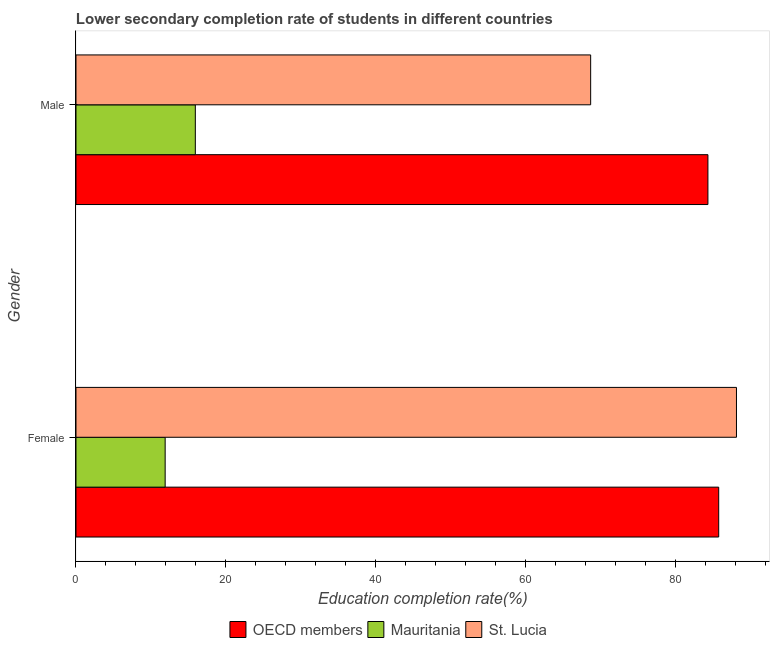How many bars are there on the 2nd tick from the top?
Your answer should be compact. 3. What is the education completion rate of female students in Mauritania?
Offer a very short reply. 11.9. Across all countries, what is the maximum education completion rate of male students?
Keep it short and to the point. 84.36. Across all countries, what is the minimum education completion rate of male students?
Your response must be concise. 15.93. In which country was the education completion rate of female students maximum?
Keep it short and to the point. St. Lucia. In which country was the education completion rate of male students minimum?
Offer a very short reply. Mauritania. What is the total education completion rate of male students in the graph?
Give a very brief answer. 168.99. What is the difference between the education completion rate of female students in St. Lucia and that in Mauritania?
Make the answer very short. 76.27. What is the difference between the education completion rate of female students in Mauritania and the education completion rate of male students in St. Lucia?
Ensure brevity in your answer.  -56.8. What is the average education completion rate of female students per country?
Offer a very short reply. 61.96. What is the difference between the education completion rate of female students and education completion rate of male students in Mauritania?
Offer a very short reply. -4.03. In how many countries, is the education completion rate of female students greater than 20 %?
Make the answer very short. 2. What is the ratio of the education completion rate of female students in OECD members to that in Mauritania?
Provide a succinct answer. 7.21. Is the education completion rate of male students in OECD members less than that in St. Lucia?
Your answer should be compact. No. In how many countries, is the education completion rate of female students greater than the average education completion rate of female students taken over all countries?
Provide a succinct answer. 2. What does the 1st bar from the top in Male represents?
Keep it short and to the point. St. Lucia. What does the 3rd bar from the bottom in Male represents?
Offer a very short reply. St. Lucia. How many countries are there in the graph?
Provide a succinct answer. 3. What is the difference between two consecutive major ticks on the X-axis?
Ensure brevity in your answer.  20. Where does the legend appear in the graph?
Offer a terse response. Bottom center. How many legend labels are there?
Your answer should be very brief. 3. How are the legend labels stacked?
Offer a very short reply. Horizontal. What is the title of the graph?
Offer a terse response. Lower secondary completion rate of students in different countries. Does "Upper middle income" appear as one of the legend labels in the graph?
Provide a succinct answer. No. What is the label or title of the X-axis?
Your response must be concise. Education completion rate(%). What is the Education completion rate(%) in OECD members in Female?
Provide a succinct answer. 85.8. What is the Education completion rate(%) of Mauritania in Female?
Provide a short and direct response. 11.9. What is the Education completion rate(%) in St. Lucia in Female?
Provide a short and direct response. 88.17. What is the Education completion rate(%) in OECD members in Male?
Ensure brevity in your answer.  84.36. What is the Education completion rate(%) of Mauritania in Male?
Your response must be concise. 15.93. What is the Education completion rate(%) in St. Lucia in Male?
Offer a terse response. 68.7. Across all Gender, what is the maximum Education completion rate(%) of OECD members?
Give a very brief answer. 85.8. Across all Gender, what is the maximum Education completion rate(%) in Mauritania?
Your answer should be compact. 15.93. Across all Gender, what is the maximum Education completion rate(%) in St. Lucia?
Your answer should be compact. 88.17. Across all Gender, what is the minimum Education completion rate(%) in OECD members?
Provide a short and direct response. 84.36. Across all Gender, what is the minimum Education completion rate(%) of Mauritania?
Provide a succinct answer. 11.9. Across all Gender, what is the minimum Education completion rate(%) in St. Lucia?
Your answer should be compact. 68.7. What is the total Education completion rate(%) of OECD members in the graph?
Offer a very short reply. 170.15. What is the total Education completion rate(%) in Mauritania in the graph?
Keep it short and to the point. 27.83. What is the total Education completion rate(%) of St. Lucia in the graph?
Your response must be concise. 156.87. What is the difference between the Education completion rate(%) of OECD members in Female and that in Male?
Your response must be concise. 1.44. What is the difference between the Education completion rate(%) of Mauritania in Female and that in Male?
Give a very brief answer. -4.03. What is the difference between the Education completion rate(%) in St. Lucia in Female and that in Male?
Give a very brief answer. 19.46. What is the difference between the Education completion rate(%) of OECD members in Female and the Education completion rate(%) of Mauritania in Male?
Your response must be concise. 69.87. What is the difference between the Education completion rate(%) of OECD members in Female and the Education completion rate(%) of St. Lucia in Male?
Your answer should be compact. 17.09. What is the difference between the Education completion rate(%) of Mauritania in Female and the Education completion rate(%) of St. Lucia in Male?
Ensure brevity in your answer.  -56.8. What is the average Education completion rate(%) in OECD members per Gender?
Offer a terse response. 85.08. What is the average Education completion rate(%) in Mauritania per Gender?
Provide a succinct answer. 13.92. What is the average Education completion rate(%) of St. Lucia per Gender?
Your answer should be very brief. 78.44. What is the difference between the Education completion rate(%) of OECD members and Education completion rate(%) of Mauritania in Female?
Give a very brief answer. 73.89. What is the difference between the Education completion rate(%) of OECD members and Education completion rate(%) of St. Lucia in Female?
Keep it short and to the point. -2.37. What is the difference between the Education completion rate(%) of Mauritania and Education completion rate(%) of St. Lucia in Female?
Provide a short and direct response. -76.27. What is the difference between the Education completion rate(%) of OECD members and Education completion rate(%) of Mauritania in Male?
Your response must be concise. 68.43. What is the difference between the Education completion rate(%) of OECD members and Education completion rate(%) of St. Lucia in Male?
Provide a short and direct response. 15.65. What is the difference between the Education completion rate(%) in Mauritania and Education completion rate(%) in St. Lucia in Male?
Keep it short and to the point. -52.77. What is the ratio of the Education completion rate(%) of OECD members in Female to that in Male?
Provide a short and direct response. 1.02. What is the ratio of the Education completion rate(%) in Mauritania in Female to that in Male?
Make the answer very short. 0.75. What is the ratio of the Education completion rate(%) of St. Lucia in Female to that in Male?
Your answer should be compact. 1.28. What is the difference between the highest and the second highest Education completion rate(%) of OECD members?
Your response must be concise. 1.44. What is the difference between the highest and the second highest Education completion rate(%) in Mauritania?
Your response must be concise. 4.03. What is the difference between the highest and the second highest Education completion rate(%) in St. Lucia?
Your answer should be compact. 19.46. What is the difference between the highest and the lowest Education completion rate(%) in OECD members?
Keep it short and to the point. 1.44. What is the difference between the highest and the lowest Education completion rate(%) of Mauritania?
Make the answer very short. 4.03. What is the difference between the highest and the lowest Education completion rate(%) of St. Lucia?
Make the answer very short. 19.46. 